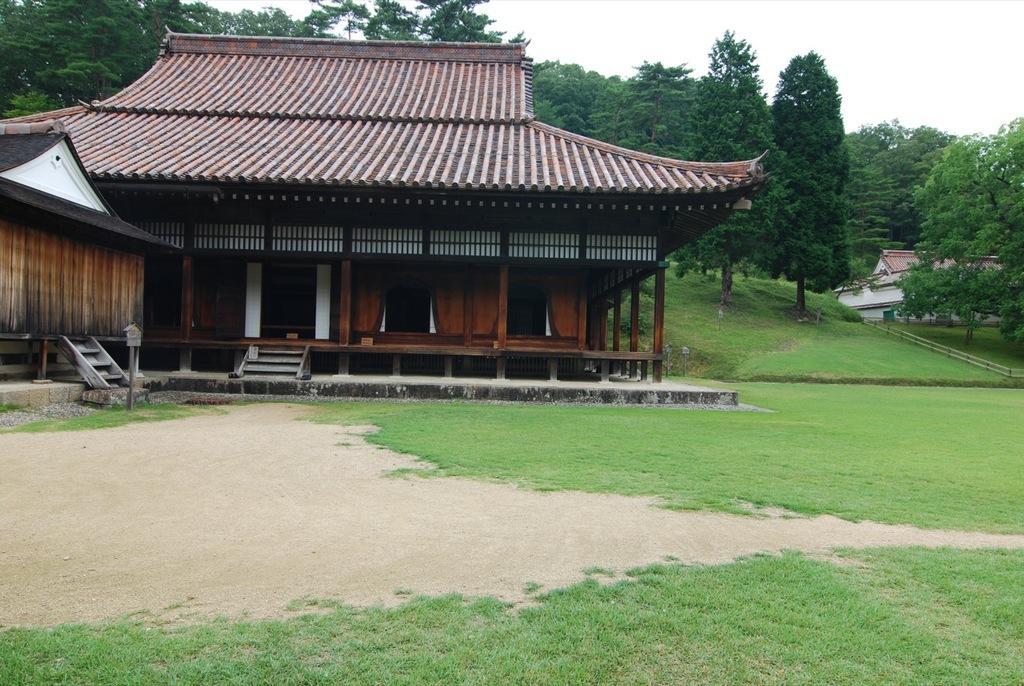Can you describe this image briefly? In this image we can see houses, stairs, there are trees, grass, fencing, also we can see the sky. 